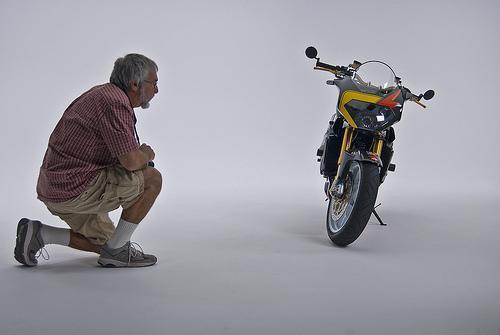How many motorbikes are there?
Give a very brief answer. 1. 